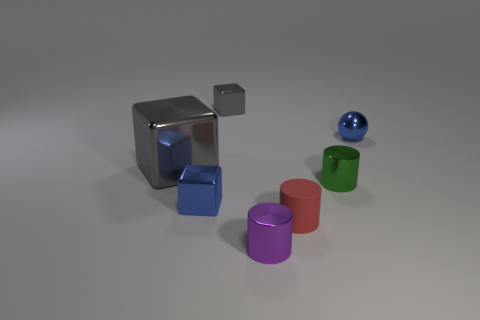What is the size of the purple cylinder that is made of the same material as the tiny green thing?
Provide a succinct answer. Small. Are there an equal number of tiny blue blocks that are to the left of the small green shiny cylinder and tiny gray metal blocks?
Make the answer very short. Yes. Does the blue metallic object that is in front of the large thing have the same shape as the gray metal thing that is behind the sphere?
Your response must be concise. Yes. There is a red thing that is the same shape as the small green metal thing; what material is it?
Provide a succinct answer. Rubber. There is a small cylinder that is behind the purple thing and in front of the blue block; what color is it?
Give a very brief answer. Red. Is there a small blue shiny thing that is on the right side of the blue metallic object on the left side of the blue metallic thing right of the tiny purple metallic cylinder?
Offer a terse response. Yes. What number of things are either gray blocks or metallic objects?
Give a very brief answer. 6. Is the green cylinder made of the same material as the small object to the right of the green metallic cylinder?
Your answer should be compact. Yes. Is there anything else that is the same color as the large cube?
Your answer should be compact. Yes. How many objects are tiny blue objects behind the small blue metal block or things on the left side of the purple shiny cylinder?
Provide a short and direct response. 4. 